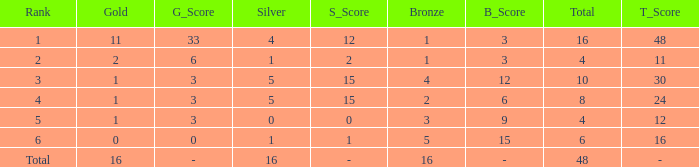How many total gold are less than 4? 0.0. 